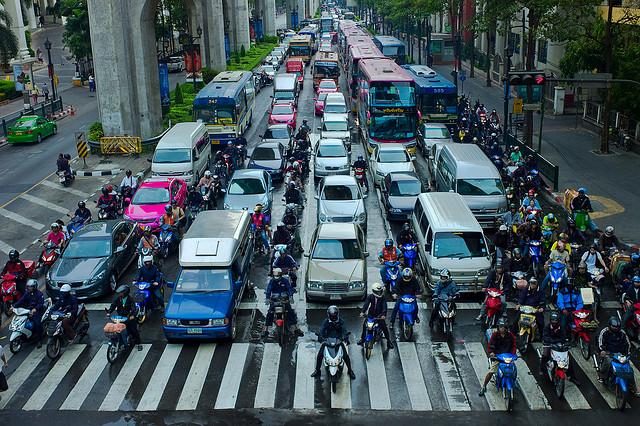How many motorcycles are in the crosswalk?
Concise answer only. 15. What do you call this type of traffic situation?
Short answer required. Traffic jam. What kind of vehicle is the pink one?
Be succinct. Car. 